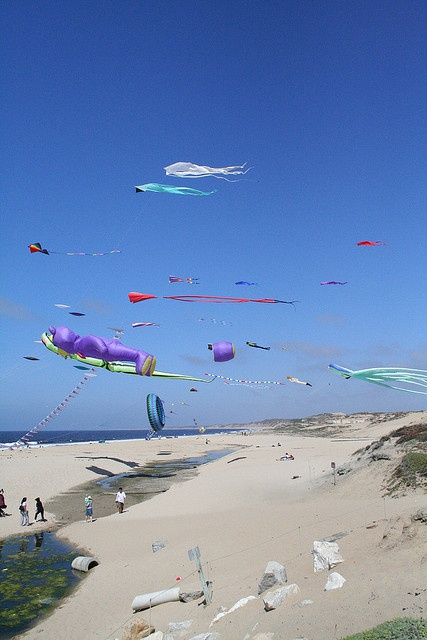Describe the objects in this image and their specific colors. I can see kite in blue and darkgray tones, kite in blue, violet, darkblue, and lightblue tones, kite in blue, teal, lightblue, and darkgray tones, kite in blue, lightgray, and darkgray tones, and kite in blue and lightblue tones in this image. 